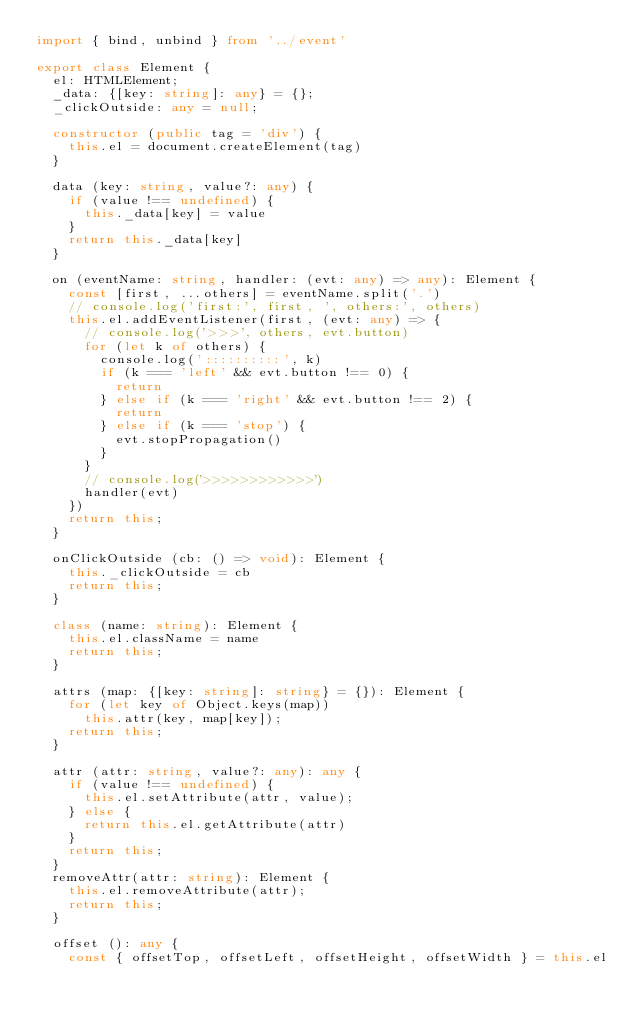<code> <loc_0><loc_0><loc_500><loc_500><_TypeScript_>import { bind, unbind } from '../event'

export class Element {
  el: HTMLElement;
  _data: {[key: string]: any} = {};
  _clickOutside: any = null;

  constructor (public tag = 'div') {
    this.el = document.createElement(tag)
  }

  data (key: string, value?: any) {
    if (value !== undefined) {
      this._data[key] = value
    }
    return this._data[key]
  }

  on (eventName: string, handler: (evt: any) => any): Element {
    const [first, ...others] = eventName.split('.')
    // console.log('first:', first, ', others:', others)
    this.el.addEventListener(first, (evt: any) => {
      // console.log('>>>', others, evt.button)
      for (let k of others) {
        console.log('::::::::::', k)
        if (k === 'left' && evt.button !== 0) {
          return
        } else if (k === 'right' && evt.button !== 2) {
          return
        } else if (k === 'stop') {
          evt.stopPropagation()
        }
      }
      // console.log('>>>>>>>>>>>>')
      handler(evt)
    })
    return this;
  }

  onClickOutside (cb: () => void): Element {
    this._clickOutside = cb
    return this;
  }

  class (name: string): Element {
    this.el.className = name
    return this;
  }

  attrs (map: {[key: string]: string} = {}): Element {
    for (let key of Object.keys(map))
      this.attr(key, map[key]);
    return this;
  }

  attr (attr: string, value?: any): any {
    if (value !== undefined) {
      this.el.setAttribute(attr, value);
    } else {
      return this.el.getAttribute(attr)
    }
    return this;
  }
  removeAttr(attr: string): Element {
    this.el.removeAttribute(attr);
    return this;
  }

  offset (): any {
    const { offsetTop, offsetLeft, offsetHeight, offsetWidth } = this.el</code> 